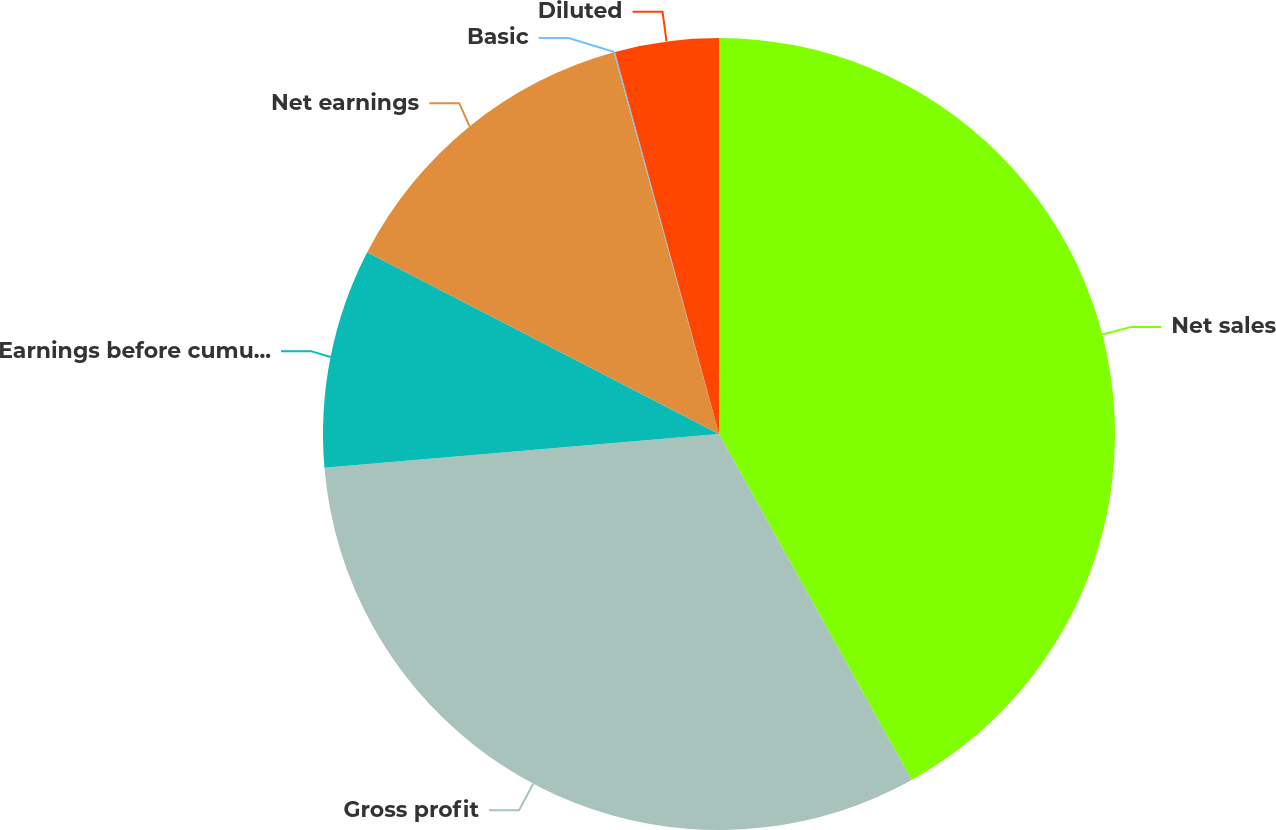Convert chart to OTSL. <chart><loc_0><loc_0><loc_500><loc_500><pie_chart><fcel>Net sales<fcel>Gross profit<fcel>Earnings before cumulative<fcel>Net earnings<fcel>Basic<fcel>Diluted<nl><fcel>41.91%<fcel>31.73%<fcel>8.95%<fcel>13.13%<fcel>0.05%<fcel>4.23%<nl></chart> 